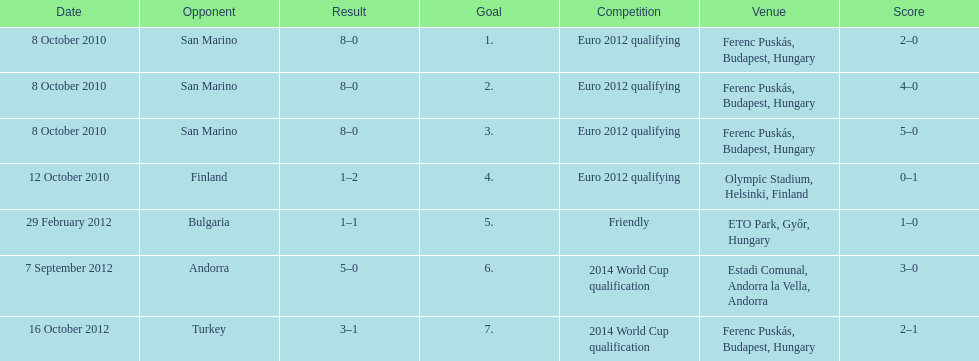How many goals were scored at the euro 2012 qualifying competition? 12. 